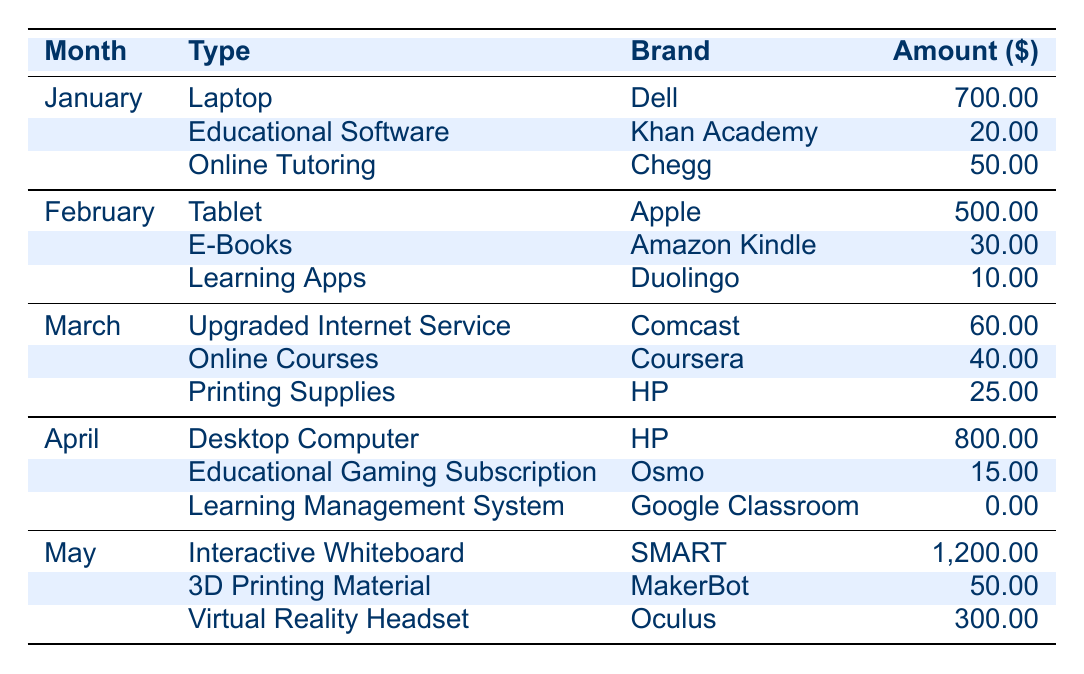What is the total amount spent on educational technology in May? In May, the expenditures are: Interactive Whiteboard (1,200), 3D Printing Material (50), and Virtual Reality Headset (300). Summing these gives: 1,200 + 50 + 300 = 1,550.
Answer: 1,550 Which brand had the highest expenditure in April? The expenditures for April are: Desktop Computer (HP, 800), Educational Gaming Subscription (Osmo, 15), and Learning Management System (Google Classroom, 0). The highest expenditure is the Desktop Computer from HP at 800.
Answer: HP How much did the household spend on online tutoring across all months? The only entry for online tutoring is in January with a cost of 50. Therefore, the total spent on online tutoring is 50.
Answer: 50 Was there any expenditure on the Learning Management System? The table shows that the Learning Management System (Google Classroom) has an amount spent of 0 in April. Hence, there was no expenditure.
Answer: Yes, 0 What is the average amount spent on tablets and laptops combined? The total expenditure for laptops is only in January (700), while the tablet expense occurs in February (500). The sum is: 700 + 500 = 1,200, and there are 2 items, thus the average is 1,200 / 2 = 600.
Answer: 600 What was the total amount spent on educational software throughout the five months? The educational software entries are January (Khan Academy, 20). Adding these gives a total expenditure of 20.
Answer: 20 Is the expenditure on online courses higher than that on printing supplies in March? In March, the online courses expenditure is for Coursera (40), and printing supplies from HP costs 25. Since 40 is greater than 25, the expenditure on online courses is indeed higher.
Answer: Yes Which month had the highest total expenditure, and what was that amount? Summing all expenditures for each month: January (700 + 20 + 50 = 770), February (500 + 30 + 10 = 540), March (60 + 40 + 25 = 125), April (800 + 15 + 0 = 815), May (1,200 + 50 + 300 = 1,550). The highest expenditure is for May at 1,550.
Answer: May, 1,550 